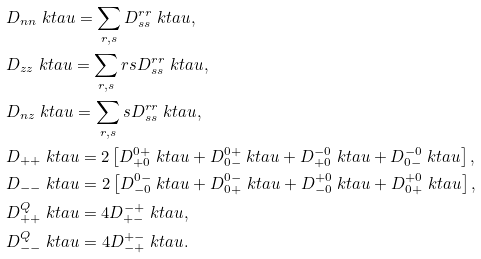<formula> <loc_0><loc_0><loc_500><loc_500>& D _ { n n } \ k t a u = \sum _ { r , s } D ^ { r r } _ { s s } \ k t a u , \\ & D _ { z z } \ k t a u = \sum _ { r , s } r s D ^ { r r } _ { s s } \ k t a u , \\ & D _ { n z } \ k t a u = \sum _ { r , s } s D ^ { r r } _ { s s } \ k t a u , \\ & D _ { + + } \ k t a u = 2 \left [ D ^ { 0 + } _ { + 0 } \ k t a u + D ^ { 0 + } _ { 0 - } \ k t a u + D ^ { - 0 } _ { + 0 } \ k t a u + D ^ { - 0 } _ { 0 - } \ k t a u \right ] , \\ & D _ { - - } \ k t a u = 2 \left [ D ^ { 0 - } _ { - 0 } \ k t a u + D ^ { 0 - } _ { 0 + } \ k t a u + D ^ { + 0 } _ { - 0 } \ k t a u + D ^ { + 0 } _ { 0 + } \ k t a u \right ] , \\ & D ^ { Q } _ { + + } \ k t a u = 4 D ^ { - + } _ { + - } \ k t a u , \\ & D ^ { Q } _ { - - } \ k t a u = 4 D ^ { + - } _ { - + } \ k t a u .</formula> 